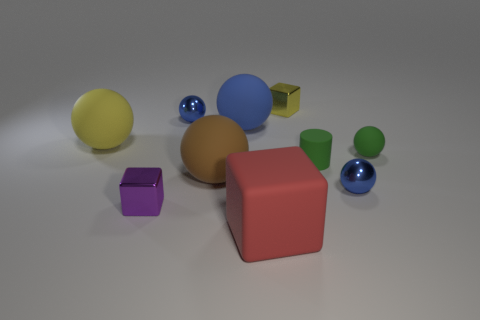There is a cylinder that is made of the same material as the green ball; what is its size?
Offer a very short reply. Small. Is the size of the metallic cube that is in front of the yellow cube the same as the brown rubber object that is on the right side of the yellow matte sphere?
Your answer should be very brief. No. How many things are tiny blue things or tiny cyan objects?
Your answer should be compact. 2. The red matte object is what shape?
Your answer should be very brief. Cube. What is the size of the blue rubber object that is the same shape as the large yellow matte thing?
Offer a terse response. Large. There is a blue object that is on the right side of the yellow object that is behind the big yellow matte object; what is its size?
Your answer should be compact. Small. Is the number of tiny green balls that are on the left side of the brown ball the same as the number of tiny metal cylinders?
Provide a succinct answer. Yes. How many other things are the same color as the large cube?
Keep it short and to the point. 0. Is the number of red objects that are behind the purple metal cube less than the number of big red matte things?
Offer a very short reply. Yes. Is there a yellow metallic object that has the same size as the purple block?
Ensure brevity in your answer.  Yes. 